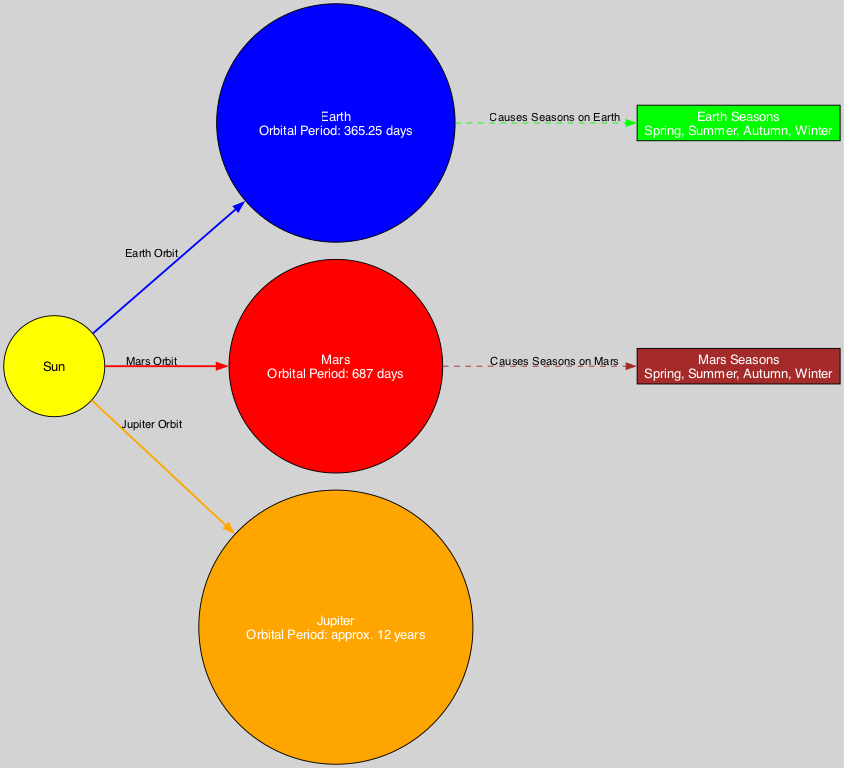What is the orbital period of Earth? The orbital period of Earth is specified in the node labeled "Earth," which indicates it is 365.25 days.
Answer: 365.25 days What color represents Mars in the diagram? The color representing Mars is indicated in the node for Mars, which shows red as its designated color.
Answer: Red How many seasons does Earth experience? The diagram includes a node labeled "Earth Seasons," which lists four seasons: Spring, Summer, Autumn, Winter. Thus, Earth experiences four seasons.
Answer: Four Which planet has the longest orbital period? The orbital period of Jupiter is indicated to be approximately 12 years, which is longer than the periods of both Earth (365.25 days) and Mars (687 days).
Answer: Jupiter What color is the edge connecting the Sun to Mars? The edge connecting the Sun to Mars is blue, as described in the edge labeled "Mars Orbit."
Answer: Red Which planet has seasons that are colored brown? The node labeled "Mars Seasons" is colored brown, indicating the color associated with the seasons on Mars.
Answer: Mars Which node describes the cause of seasons on Earth? The edge from Earth to the node labeled "Earth Seasons" indicates that this node describes the cause of seasons on Earth, confirming its relationship.
Answer: Earth Seasons What type of diagram is being represented? The elements within the diagram illustrate planetary orbits and their seasons, making it an Astronomy diagram.
Answer: Astronomy diagram How is the relationship between the Sun and Jupiter depicted? The relationship is shown as an edge labeled "Jupiter Orbit" connecting the Sun to Jupiter, indicating the Sun's role as the focal point of Jupiter's orbit.
Answer: Jupiter Orbit 